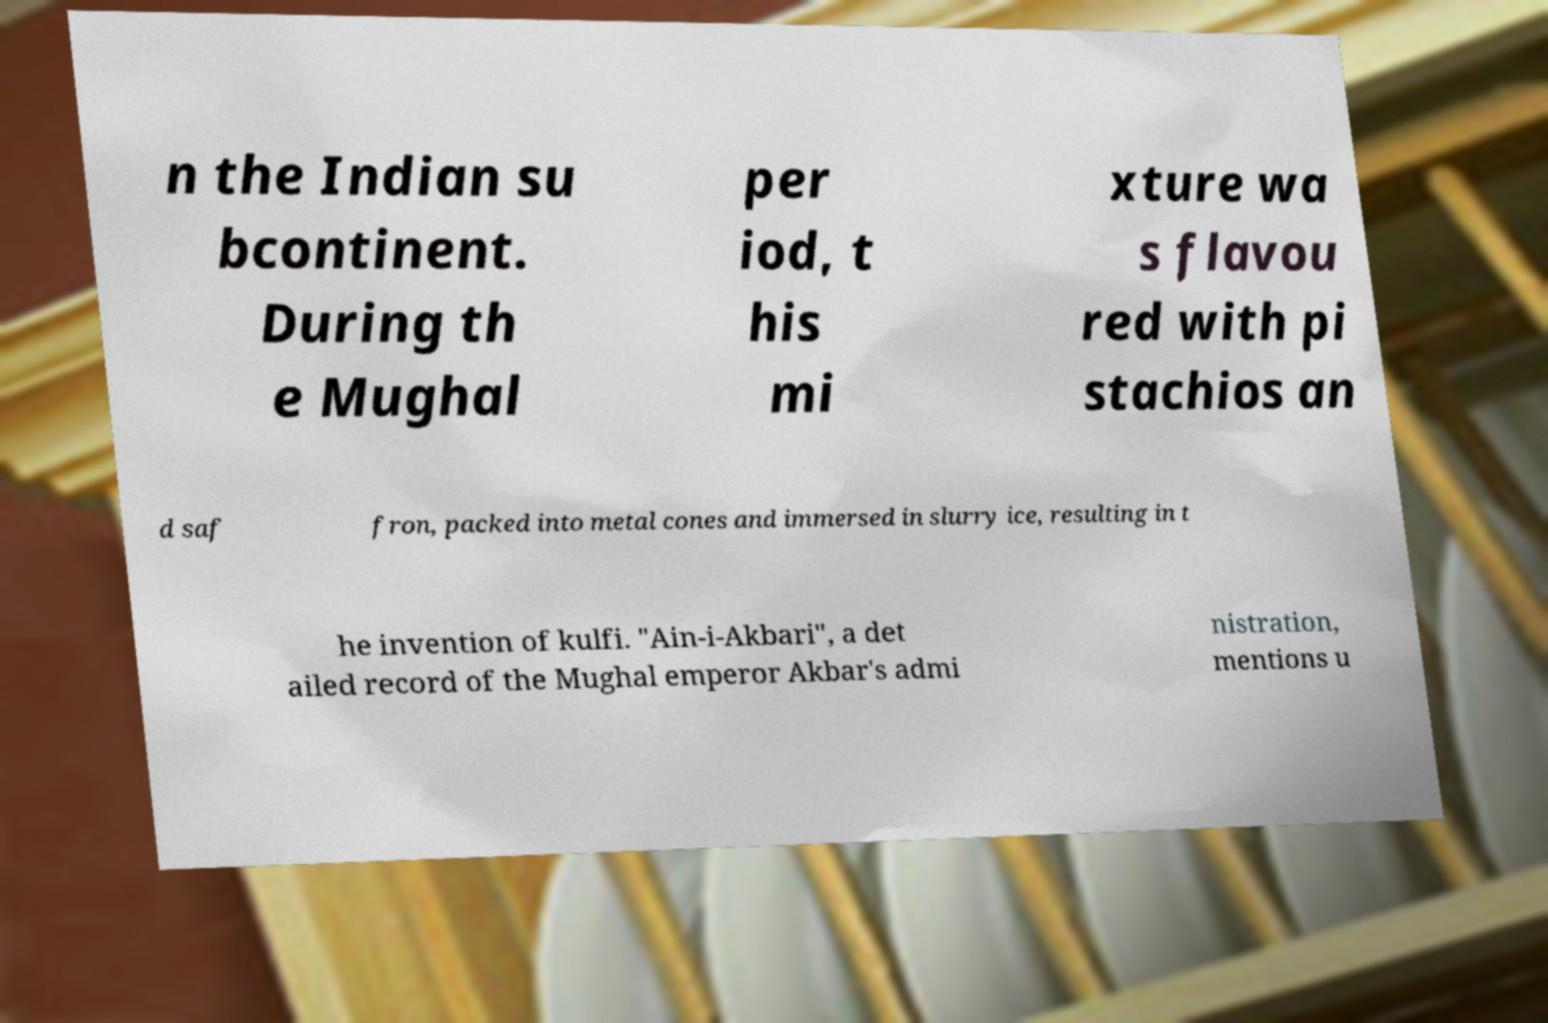Please read and relay the text visible in this image. What does it say? n the Indian su bcontinent. During th e Mughal per iod, t his mi xture wa s flavou red with pi stachios an d saf fron, packed into metal cones and immersed in slurry ice, resulting in t he invention of kulfi. "Ain-i-Akbari", a det ailed record of the Mughal emperor Akbar's admi nistration, mentions u 